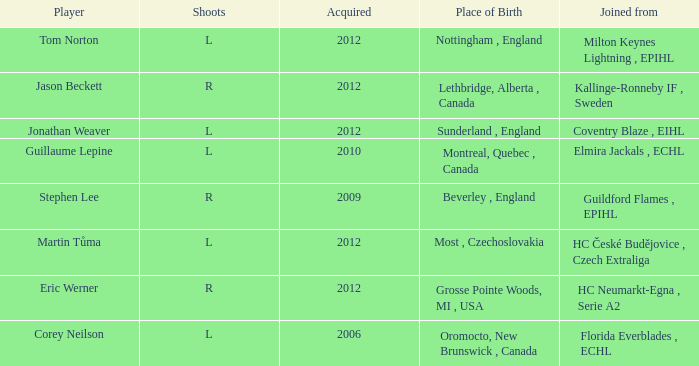Who took over tom norton? 2012.0. 